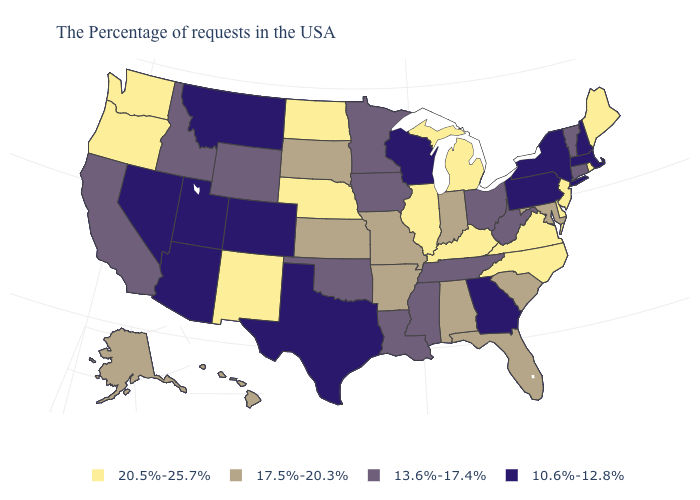What is the highest value in the Northeast ?
Quick response, please. 20.5%-25.7%. What is the highest value in the USA?
Answer briefly. 20.5%-25.7%. Name the states that have a value in the range 13.6%-17.4%?
Keep it brief. Vermont, Connecticut, West Virginia, Ohio, Tennessee, Mississippi, Louisiana, Minnesota, Iowa, Oklahoma, Wyoming, Idaho, California. Does North Carolina have the highest value in the USA?
Quick response, please. Yes. Which states have the lowest value in the USA?
Short answer required. Massachusetts, New Hampshire, New York, Pennsylvania, Georgia, Wisconsin, Texas, Colorado, Utah, Montana, Arizona, Nevada. What is the lowest value in the USA?
Write a very short answer. 10.6%-12.8%. What is the value of Florida?
Quick response, please. 17.5%-20.3%. Does Idaho have a higher value than Oklahoma?
Write a very short answer. No. Which states have the lowest value in the MidWest?
Keep it brief. Wisconsin. What is the highest value in the Northeast ?
Give a very brief answer. 20.5%-25.7%. What is the value of Hawaii?
Concise answer only. 17.5%-20.3%. What is the lowest value in the USA?
Answer briefly. 10.6%-12.8%. Name the states that have a value in the range 10.6%-12.8%?
Give a very brief answer. Massachusetts, New Hampshire, New York, Pennsylvania, Georgia, Wisconsin, Texas, Colorado, Utah, Montana, Arizona, Nevada. Does North Dakota have the highest value in the MidWest?
Write a very short answer. Yes. What is the highest value in the USA?
Concise answer only. 20.5%-25.7%. 